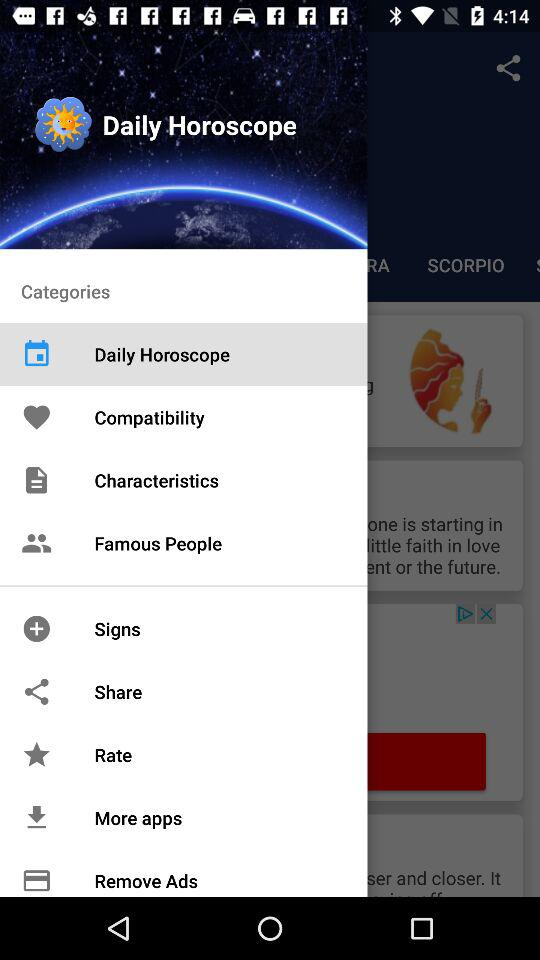Which item is selected in "Categories"? The item that is selected in "Categories" is "Daily Horoscope". 